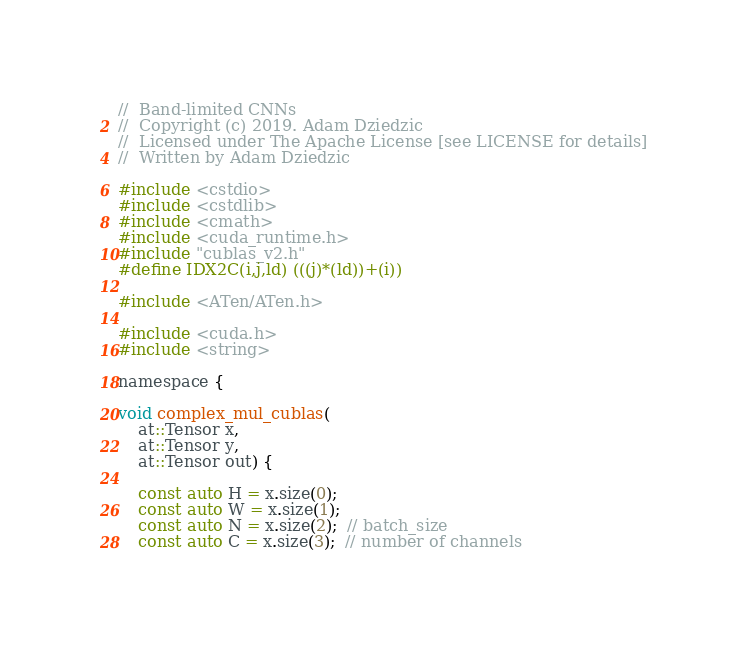<code> <loc_0><loc_0><loc_500><loc_500><_Cuda_>//  Band-limited CNNs
//  Copyright (c) 2019. Adam Dziedzic
//  Licensed under The Apache License [see LICENSE for details]
//  Written by Adam Dziedzic

#include <cstdio>
#include <cstdlib>
#include <cmath>
#include <cuda_runtime.h>
#include "cublas_v2.h"
#define IDX2C(i,j,ld) (((j)*(ld))+(i))

#include <ATen/ATen.h>

#include <cuda.h>
#include <string>

namespace {

void complex_mul_cublas(
    at::Tensor x,
    at::Tensor y,
    at::Tensor out) {

    const auto H = x.size(0);
    const auto W = x.size(1);
    const auto N = x.size(2);  // batch_size
    const auto C = x.size(3);  // number of channels</code> 